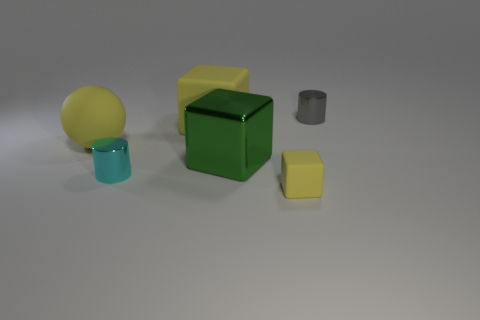Is there a yellow object right of the cylinder that is in front of the small cylinder behind the big shiny object?
Ensure brevity in your answer.  Yes. The other thing that is the same shape as the cyan metallic object is what size?
Make the answer very short. Small. Are any yellow things visible?
Your answer should be compact. Yes. There is a large ball; is its color the same as the small shiny cylinder that is in front of the tiny gray metal thing?
Provide a short and direct response. No. How big is the cylinder to the left of the tiny cylinder that is behind the yellow cube on the left side of the green metal block?
Your answer should be compact. Small. How many large cubes have the same color as the ball?
Ensure brevity in your answer.  1. How many things are either large yellow matte spheres or yellow matte blocks that are on the left side of the tiny yellow rubber thing?
Offer a very short reply. 2. What color is the large sphere?
Your answer should be compact. Yellow. What color is the matte sphere to the left of the tiny cube?
Provide a short and direct response. Yellow. How many tiny metal objects are behind the yellow cube that is on the left side of the big green shiny block?
Provide a short and direct response. 1. 